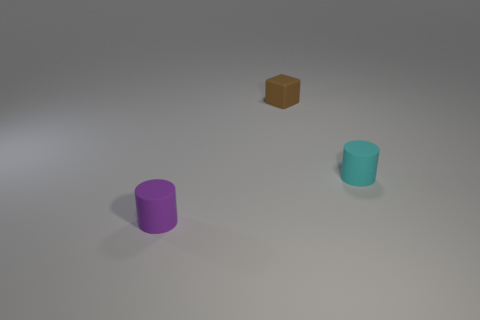Subtract all blocks. How many objects are left? 2 Add 2 cyan objects. How many objects exist? 5 Subtract all cyan cylinders. Subtract all green cubes. How many cylinders are left? 1 Subtract all small matte things. Subtract all yellow matte spheres. How many objects are left? 0 Add 1 small brown blocks. How many small brown blocks are left? 2 Add 2 big purple rubber things. How many big purple rubber things exist? 2 Subtract 0 red spheres. How many objects are left? 3 